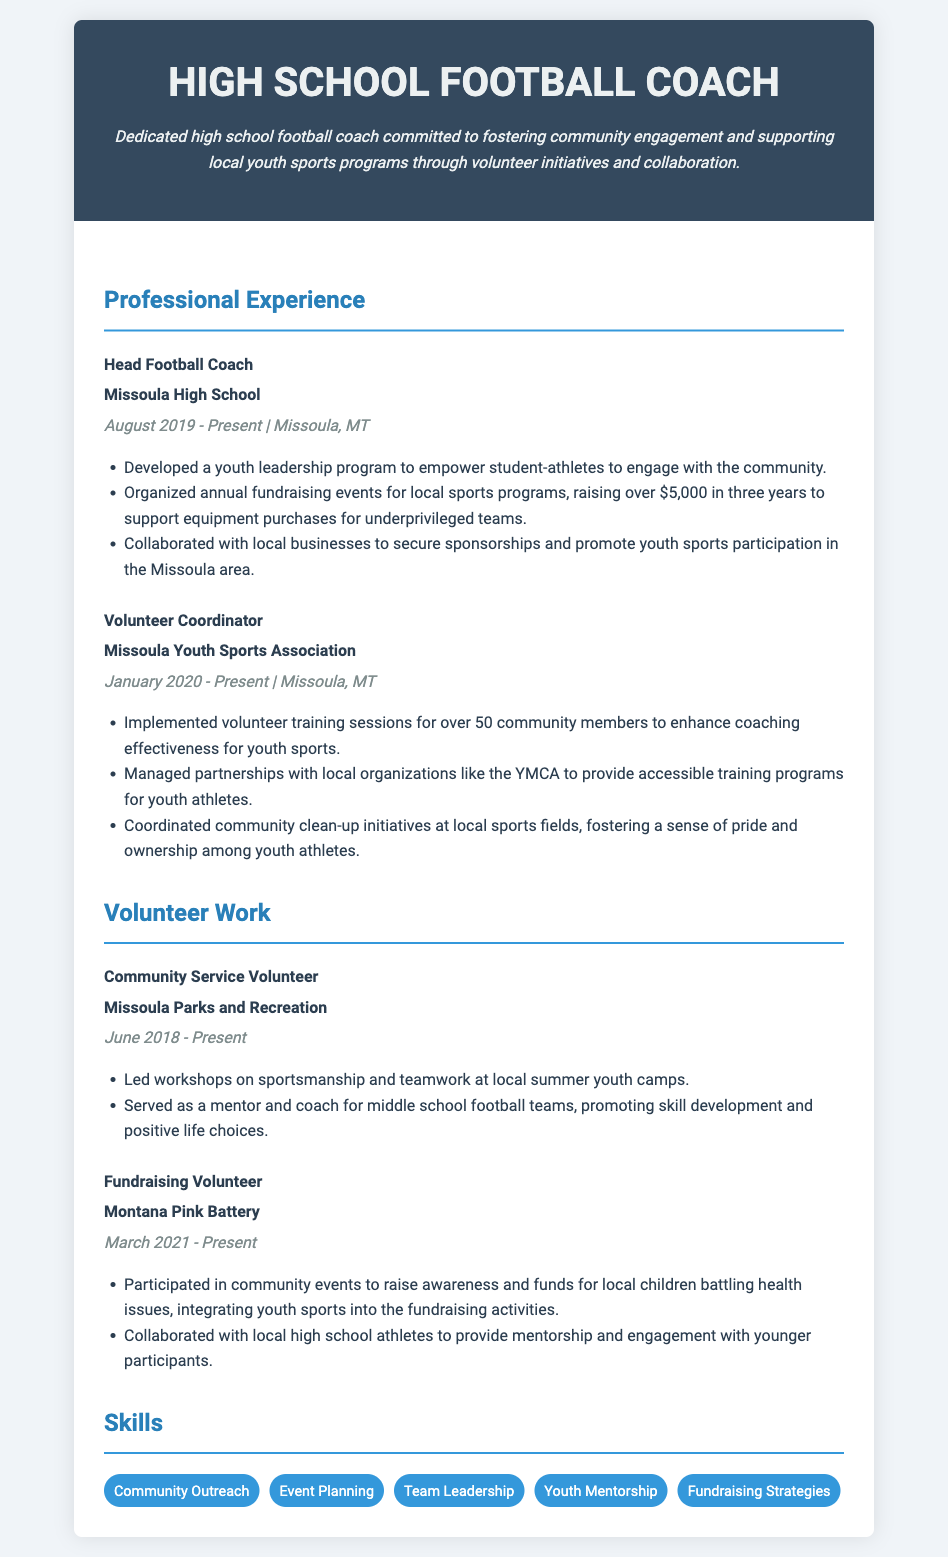What is the current job title of the individual? The job title is provided in the header of the resume.
Answer: Head Football Coach Where does the individual currently work? The name of the organization is listed under the job title in the professional experience section.
Answer: Missoula High School What is the duration of the Head Football Coach position? The dates are provided next to the job title in the experience section.
Answer: August 2019 - Present How much money has been raised for local sports programs? The amount raised is specified in a bullet point of the experience section under the Head Football Coach position.
Answer: Over $5,000 How many community members were trained as volunteers? The number of trained volunteers is mentioned in the bullet points under the Volunteer Coordinator section.
Answer: Over 50 What initiative did the individual develop for student athletes? The initiative is mentioned in the bullet points under the Head Football Coach position.
Answer: Youth leadership program In which year did the individual start their role as Volunteer Coordinator? The starting year is noted next to the position title in the professional experience section.
Answer: 2020 What type of events did the individual participate in to raise awareness for local children? The type of events is mentioned in the bullet points under the Fundraising Volunteer section.
Answer: Community events What organization is associated with the fundraising volunteer work? The organization is listed next to the job title in the volunteer experience section.
Answer: Montana Pink Battery 